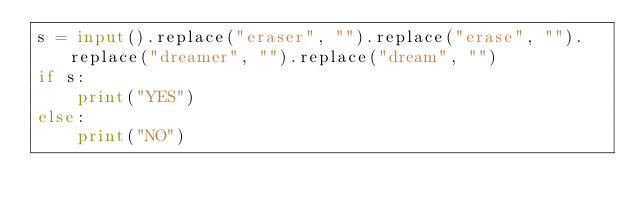Convert code to text. <code><loc_0><loc_0><loc_500><loc_500><_Python_>s = input().replace("eraser", "").replace("erase", "").replace("dreamer", "").replace("dream", "")
if s:
    print("YES")
else:
    print("NO")</code> 